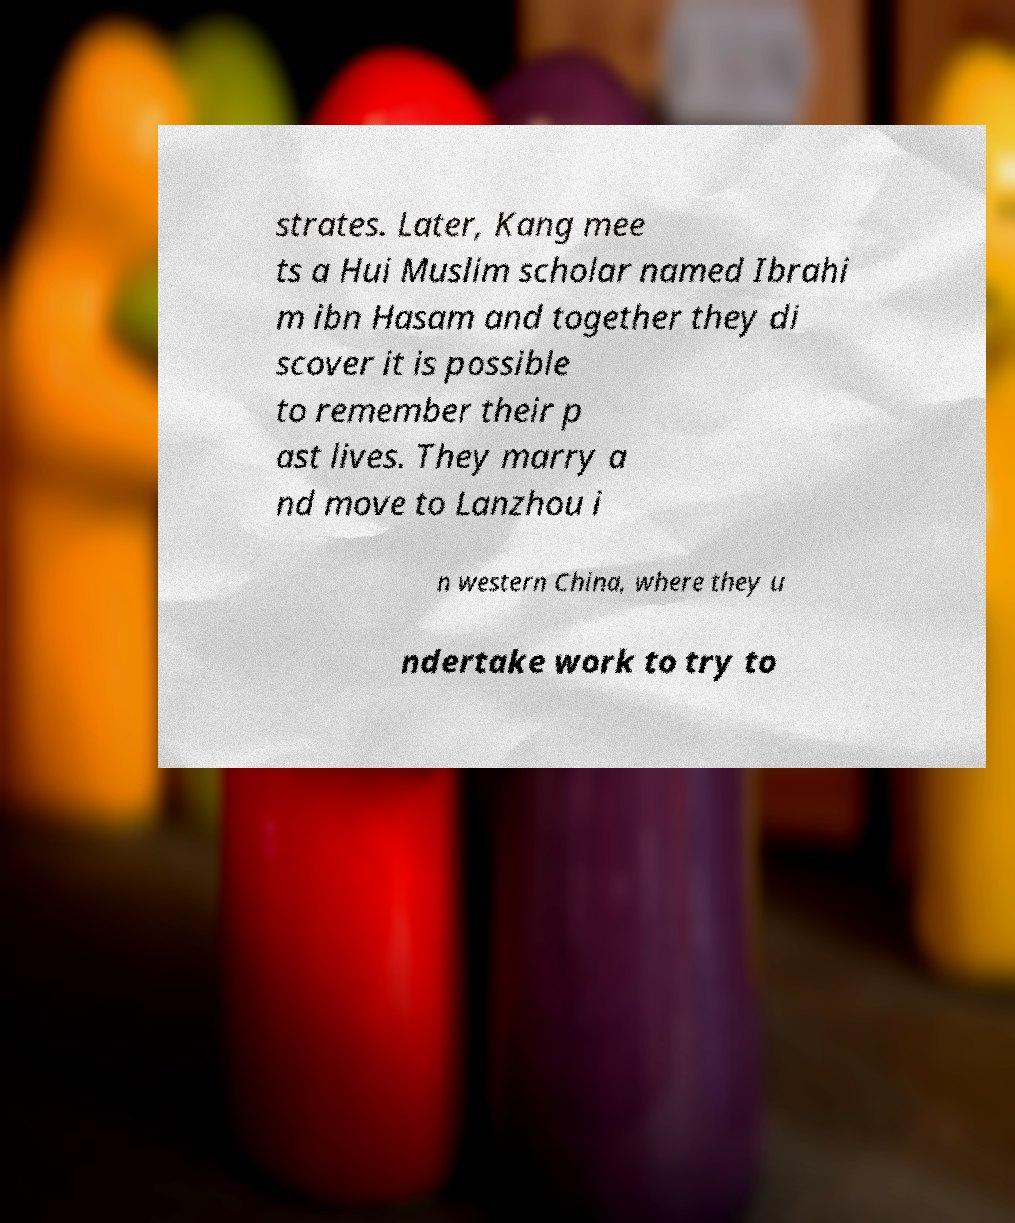There's text embedded in this image that I need extracted. Can you transcribe it verbatim? strates. Later, Kang mee ts a Hui Muslim scholar named Ibrahi m ibn Hasam and together they di scover it is possible to remember their p ast lives. They marry a nd move to Lanzhou i n western China, where they u ndertake work to try to 